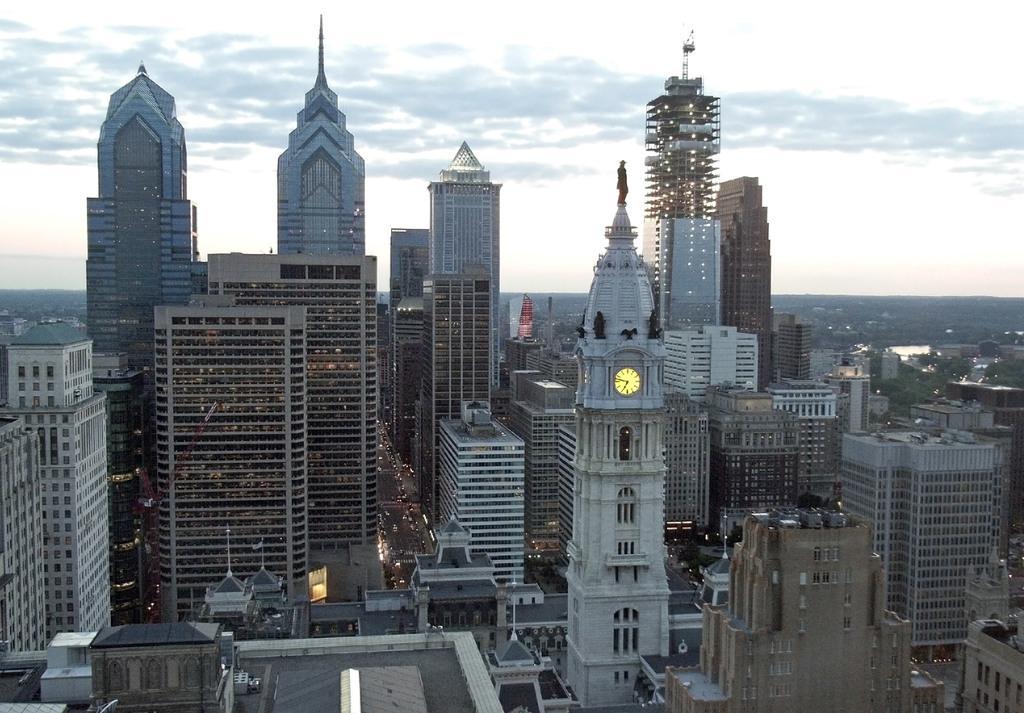Describe this image in one or two sentences. In this image, we can see some buildings and at the top there is a sky which is cloudy. 